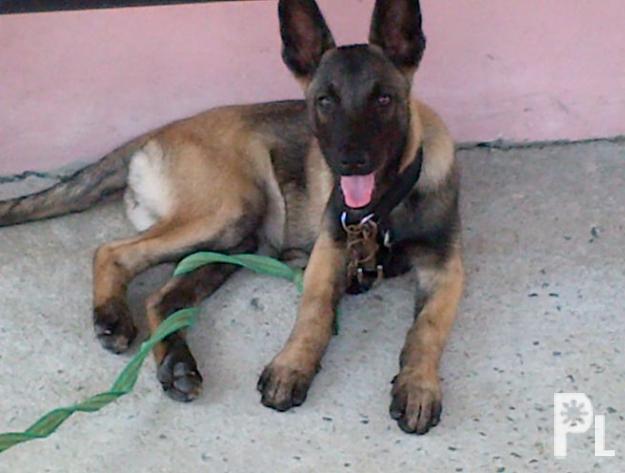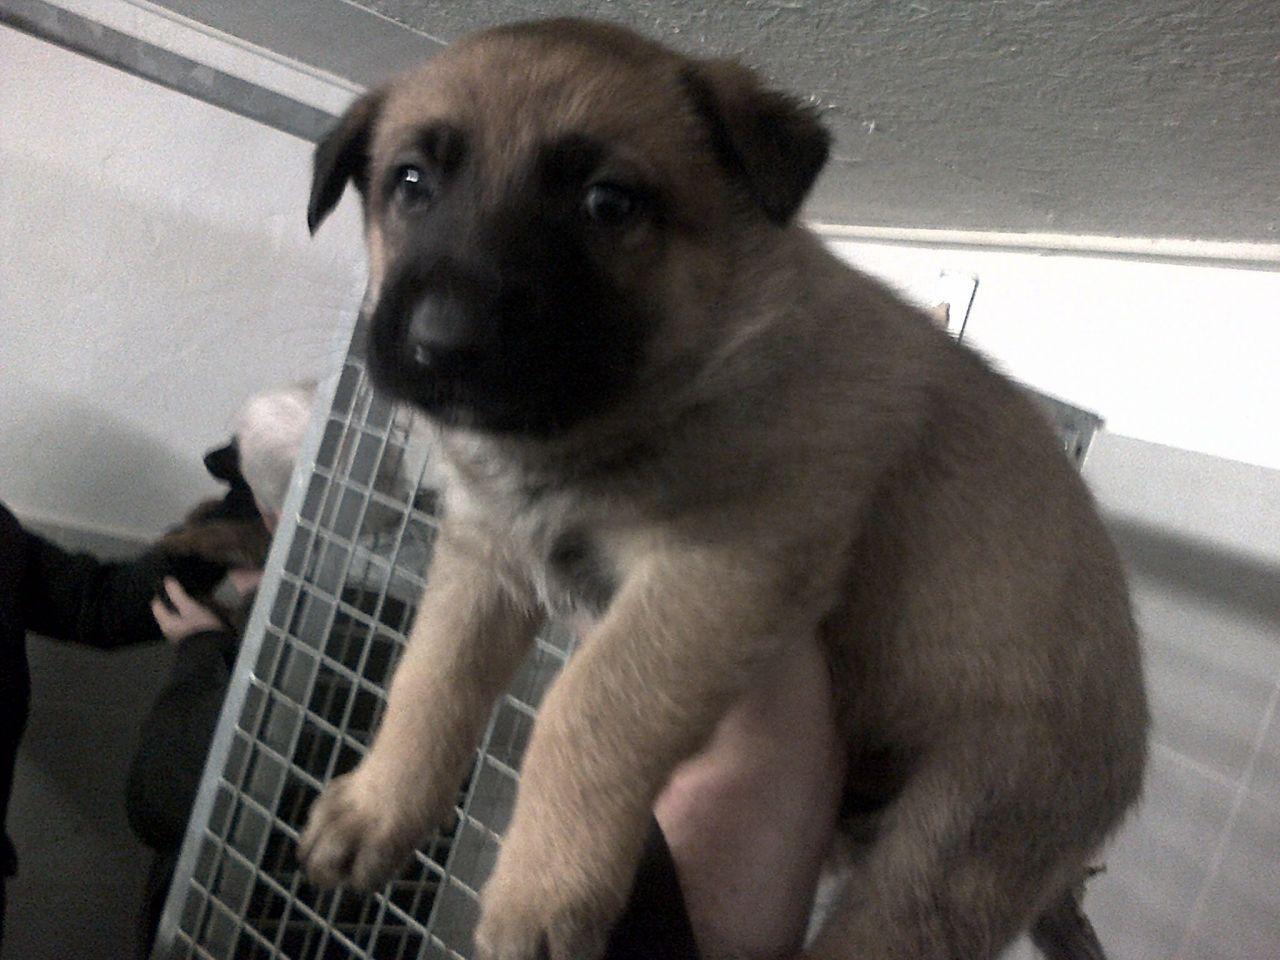The first image is the image on the left, the second image is the image on the right. Given the left and right images, does the statement "The dog in the image on the left is on a leash." hold true? Answer yes or no. Yes. 